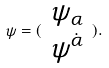<formula> <loc_0><loc_0><loc_500><loc_500>\psi = ( \begin{array} { c } \psi _ { \alpha } \\ \psi ^ { \dot { \alpha } } \end{array} ) .</formula> 